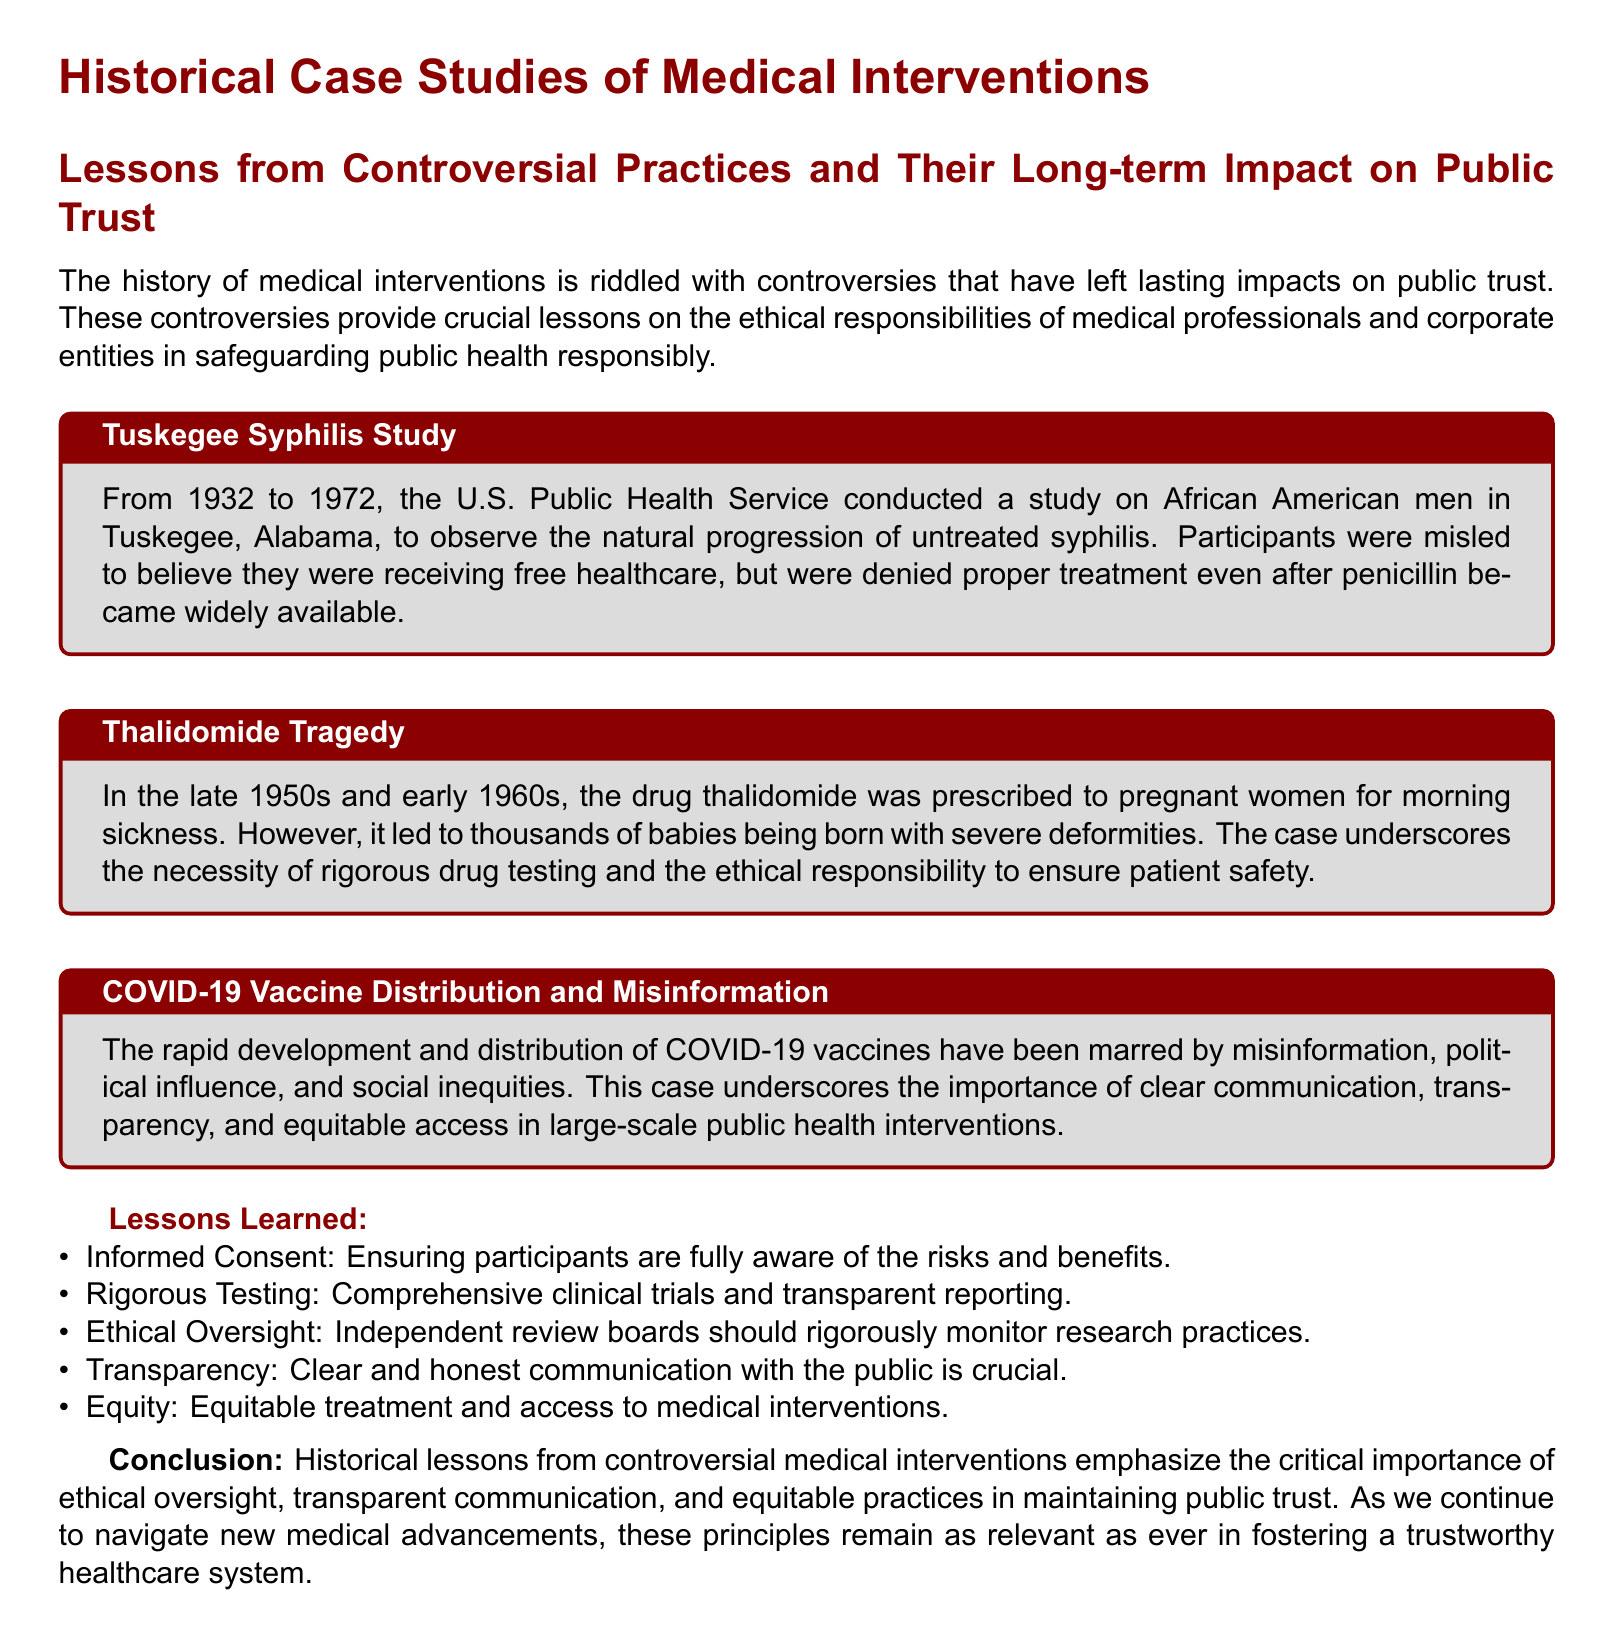What was the duration of the Tuskegee Syphilis Study? The Tuskegee Syphilis Study lasted from 1932 to 1972, indicating a 40-year duration.
Answer: 40 years What was thalidomide prescribed for? Thalidomide was prescribed to pregnant women for morning sickness, illustrating the context of its use.
Answer: Morning sickness What key issue is highlighted in the COVID-19 vaccine case study? The COVID-19 vaccine case study highlights the importance of clear communication, transparency, and equitable access.
Answer: Misinformation What does "Informed Consent" refer to in the lessons learned section? "Informed Consent" refers to ensuring participants are fully aware of the risks and benefits before participating in medical studies.
Answer: Risks and benefits Which research oversight mechanism is emphasized in the lessons learned? The document emphasizes the necessity for independent review boards to rigorously monitor research practices as part of ethical oversight.
Answer: Independent review boards What is a major lesson learned from the Tuskegee Syphilis Study? A major lesson learned from the Tuskegee Syphilis Study pertains to the necessity of ethical oversight in medical research practices.
Answer: Ethical oversight What is the primary focus of the document? The primary focus of the document is on historical case studies of medical interventions and their impact on public trust.
Answer: Medical interventions What is one effect of the Thalidomide Tragedy on drug regulations? The Thalidomide Tragedy led to the establishment of rigorous drug testing as a necessary safeguard for patient safety.
Answer: Rigorous drug testing What conclusion does the document draw regarding public trust? The conclusion of the document states that maintaining public trust requires ethical oversight and transparent communication in healthcare.
Answer: Ethical oversight 